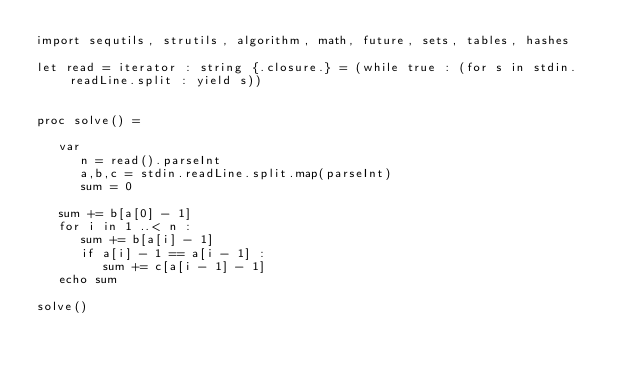<code> <loc_0><loc_0><loc_500><loc_500><_Nim_>import sequtils, strutils, algorithm, math, future, sets, tables, hashes

let read = iterator : string {.closure.} = (while true : (for s in stdin.readLine.split : yield s))


proc solve() =
   
   var
      n = read().parseInt
      a,b,c = stdin.readLine.split.map(parseInt)
      sum = 0
   
   sum += b[a[0] - 1]
   for i in 1 ..< n : 
      sum += b[a[i] - 1]
      if a[i] - 1 == a[i - 1] : 
         sum += c[a[i - 1] - 1]
   echo sum

solve()</code> 